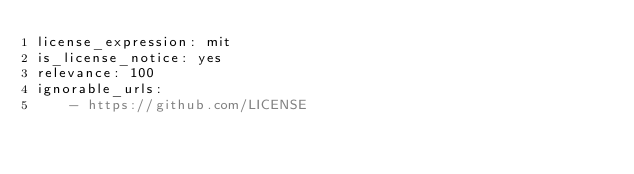Convert code to text. <code><loc_0><loc_0><loc_500><loc_500><_YAML_>license_expression: mit
is_license_notice: yes
relevance: 100
ignorable_urls:
    - https://github.com/LICENSE
</code> 